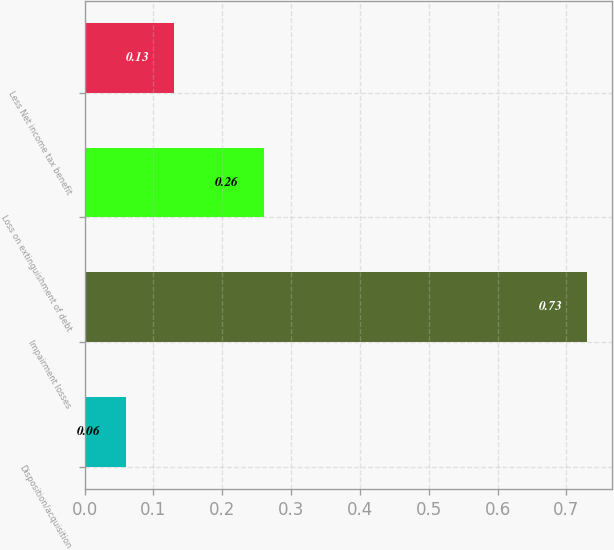Convert chart. <chart><loc_0><loc_0><loc_500><loc_500><bar_chart><fcel>Disposition/acquisition<fcel>Impairment losses<fcel>Loss on extinguishment of debt<fcel>Less Net income tax benefit<nl><fcel>0.06<fcel>0.73<fcel>0.26<fcel>0.13<nl></chart> 